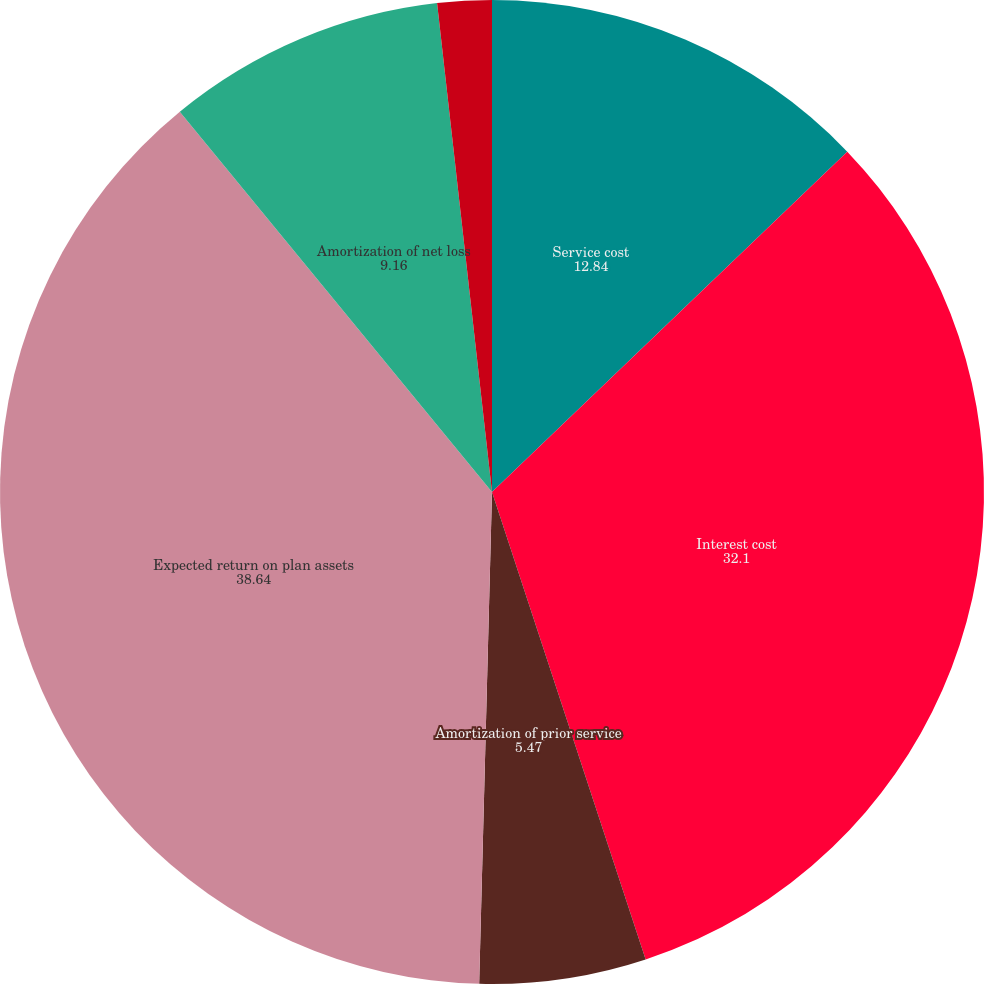Convert chart to OTSL. <chart><loc_0><loc_0><loc_500><loc_500><pie_chart><fcel>Service cost<fcel>Interest cost<fcel>Amortization of prior service<fcel>Expected return on plan assets<fcel>Amortization of net loss<fcel>Special termination benefits<nl><fcel>12.84%<fcel>32.1%<fcel>5.47%<fcel>38.64%<fcel>9.16%<fcel>1.78%<nl></chart> 